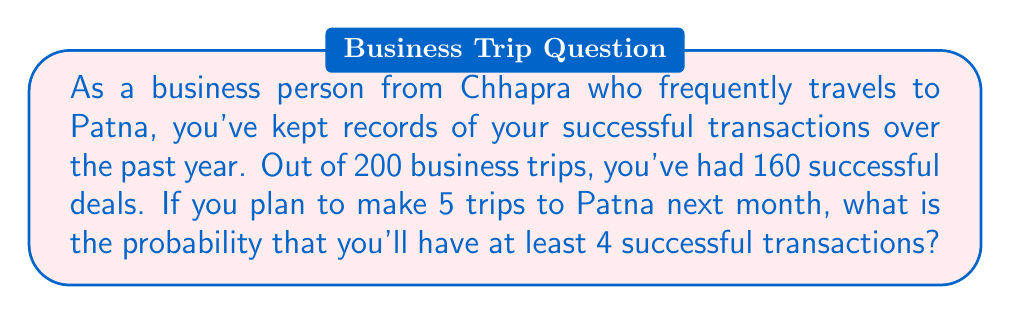What is the answer to this math problem? Let's approach this step-by-step using the binomial probability distribution:

1) First, we need to calculate the probability of a single successful transaction:
   $p = \frac{160}{200} = 0.8$ or 80%

2) The probability of an unsuccessful transaction is:
   $q = 1 - p = 1 - 0.8 = 0.2$ or 20%

3) We want the probability of at least 4 successes out of 5 trips. This means we need to calculate the probability of 4 successes and 5 successes, then add them together.

4) The binomial probability formula is:
   $$P(X = k) = \binom{n}{k} p^k q^{n-k}$$
   where $n$ is the number of trials, $k$ is the number of successes, $p$ is the probability of success, and $q$ is the probability of failure.

5) For 4 successes out of 5:
   $$P(X = 4) = \binom{5}{4} (0.8)^4 (0.2)^1 = 5 \cdot 0.4096 \cdot 0.2 = 0.4096$$

6) For 5 successes out of 5:
   $$P(X = 5) = \binom{5}{5} (0.8)^5 (0.2)^0 = 1 \cdot 0.32768 \cdot 1 = 0.32768$$

7) The probability of at least 4 successes is the sum of these probabilities:
   $$P(X \geq 4) = P(X = 4) + P(X = 5) = 0.4096 + 0.32768 = 0.73728$$

Therefore, the probability of having at least 4 successful transactions out of 5 trips is approximately 0.73728 or 73.728%.
Answer: 0.73728 